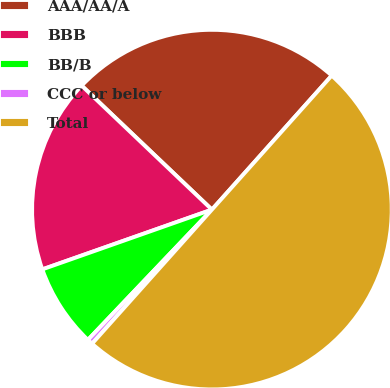Convert chart to OTSL. <chart><loc_0><loc_0><loc_500><loc_500><pie_chart><fcel>AAA/AA/A<fcel>BBB<fcel>BB/B<fcel>CCC or below<fcel>Total<nl><fcel>24.5%<fcel>17.5%<fcel>7.5%<fcel>0.5%<fcel>50.0%<nl></chart> 